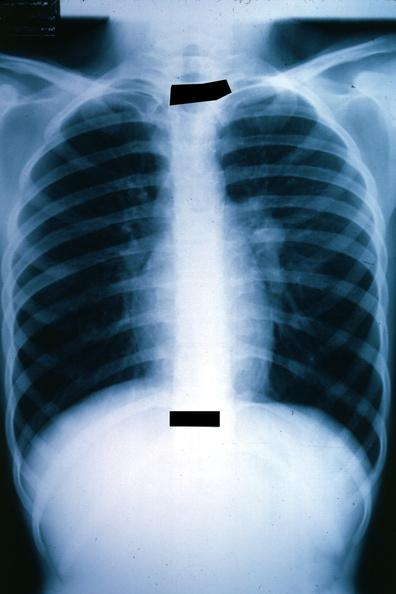how is x-ray chest shown left hilar mass tumor in hilar?
Answer the question using a single word or phrase. Node 